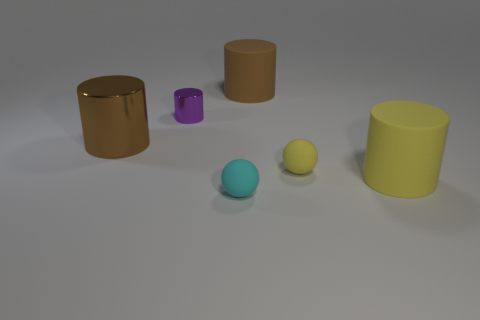There is a big cylinder that is the same color as the big metallic thing; what is its material?
Provide a short and direct response. Rubber. What shape is the rubber thing that is the same color as the big metal cylinder?
Give a very brief answer. Cylinder. There is a object that is the same color as the big shiny cylinder; what size is it?
Your answer should be compact. Large. There is a cylinder that is the same size as the cyan rubber thing; what color is it?
Ensure brevity in your answer.  Purple. Is the number of big matte objects on the left side of the cyan sphere less than the number of brown metal cylinders right of the tiny purple metal thing?
Your answer should be compact. No. Does the matte cylinder in front of the brown metallic cylinder have the same size as the big metal thing?
Your answer should be very brief. Yes. There is a brown object that is in front of the large brown matte thing; what shape is it?
Provide a short and direct response. Cylinder. Are there more big blue spheres than yellow rubber cylinders?
Provide a succinct answer. No. Does the small matte ball right of the cyan sphere have the same color as the large metal cylinder?
Offer a terse response. No. What number of things are either small matte spheres in front of the yellow cylinder or objects in front of the small purple metallic object?
Give a very brief answer. 4. 